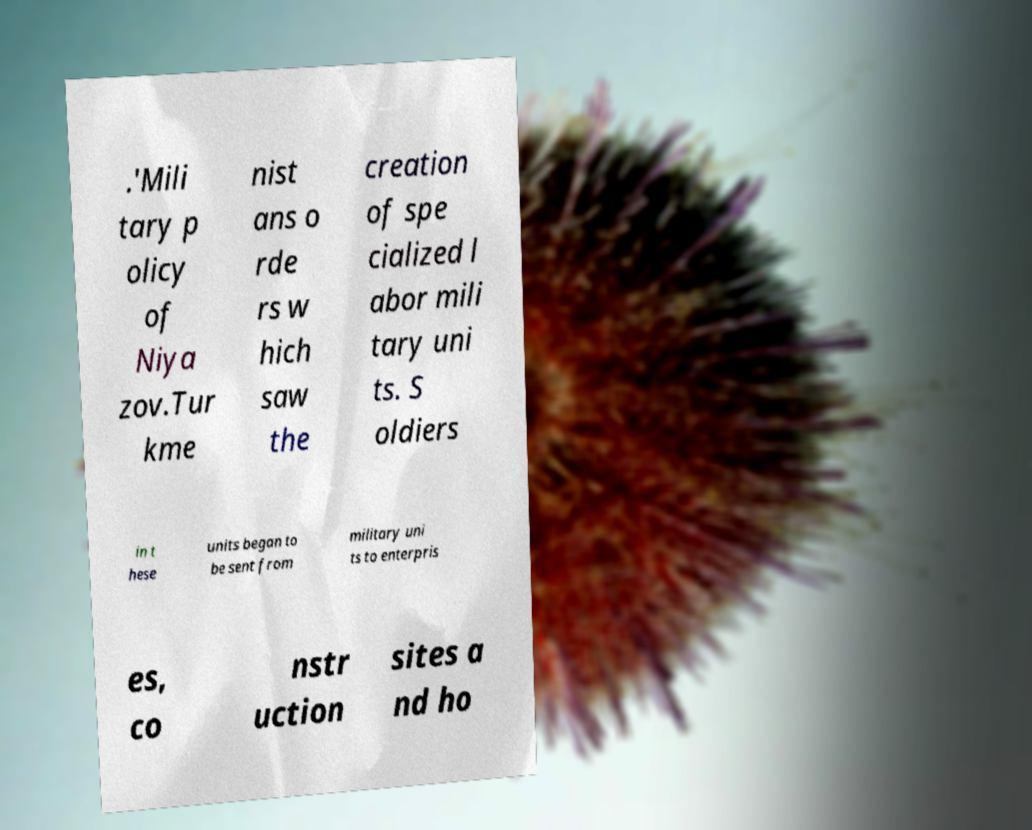Please read and relay the text visible in this image. What does it say? .'Mili tary p olicy of Niya zov.Tur kme nist ans o rde rs w hich saw the creation of spe cialized l abor mili tary uni ts. S oldiers in t hese units began to be sent from military uni ts to enterpris es, co nstr uction sites a nd ho 